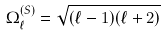Convert formula to latex. <formula><loc_0><loc_0><loc_500><loc_500>\Omega ^ { ( S ) } _ { \ell } = \sqrt { ( \ell - 1 ) ( \ell + 2 ) }</formula> 